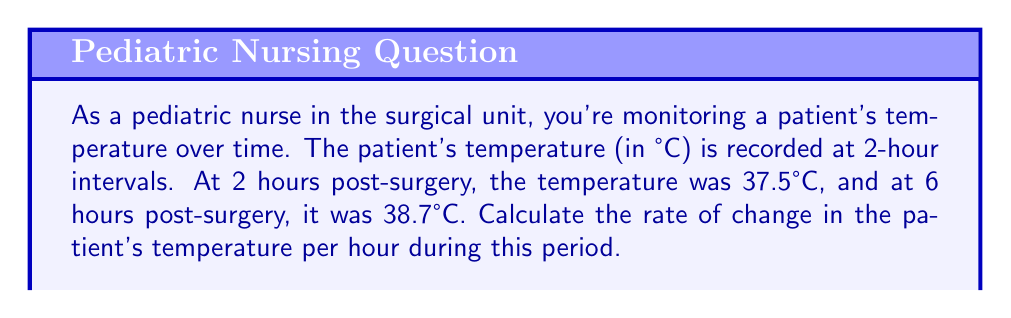Solve this math problem. To solve this problem, we'll use the slope formula, which represents the rate of change between two points. The slope formula is:

$$ m = \frac{y_2 - y_1}{x_2 - x_1} $$

Where:
- $m$ is the slope (rate of change)
- $(x_1, y_1)$ is the first point
- $(x_2, y_2)$ is the second point

In this case:
- $x_1 = 2$ hours, $y_1 = 37.5°C$
- $x_2 = 6$ hours, $y_2 = 38.7°C$

Let's plug these values into the formula:

$$ m = \frac{38.7 - 37.5}{6 - 2} = \frac{1.2}{4} = 0.3 $$

This means the temperature is increasing at a rate of 0.3°C per hour.

To verify:
- Over 4 hours, the total increase would be $4 \times 0.3 = 1.2°C$
- Indeed, $38.7°C - 37.5°C = 1.2°C$
Answer: The rate of change in the patient's temperature is $0.3°C$ per hour. 